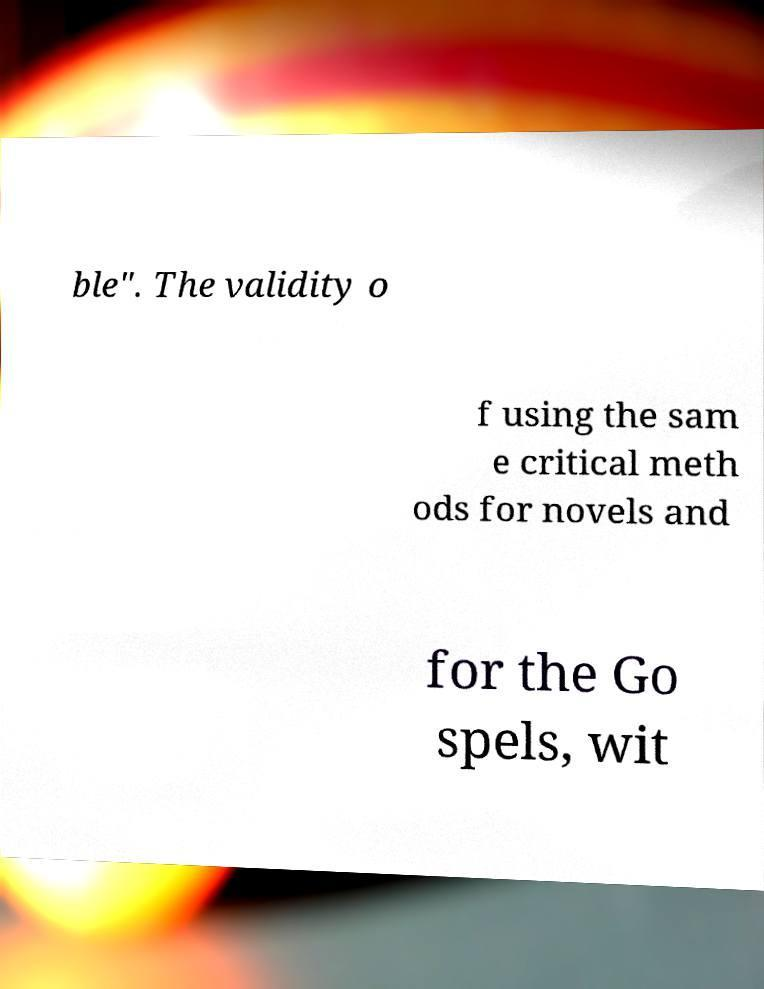What messages or text are displayed in this image? I need them in a readable, typed format. ble". The validity o f using the sam e critical meth ods for novels and for the Go spels, wit 